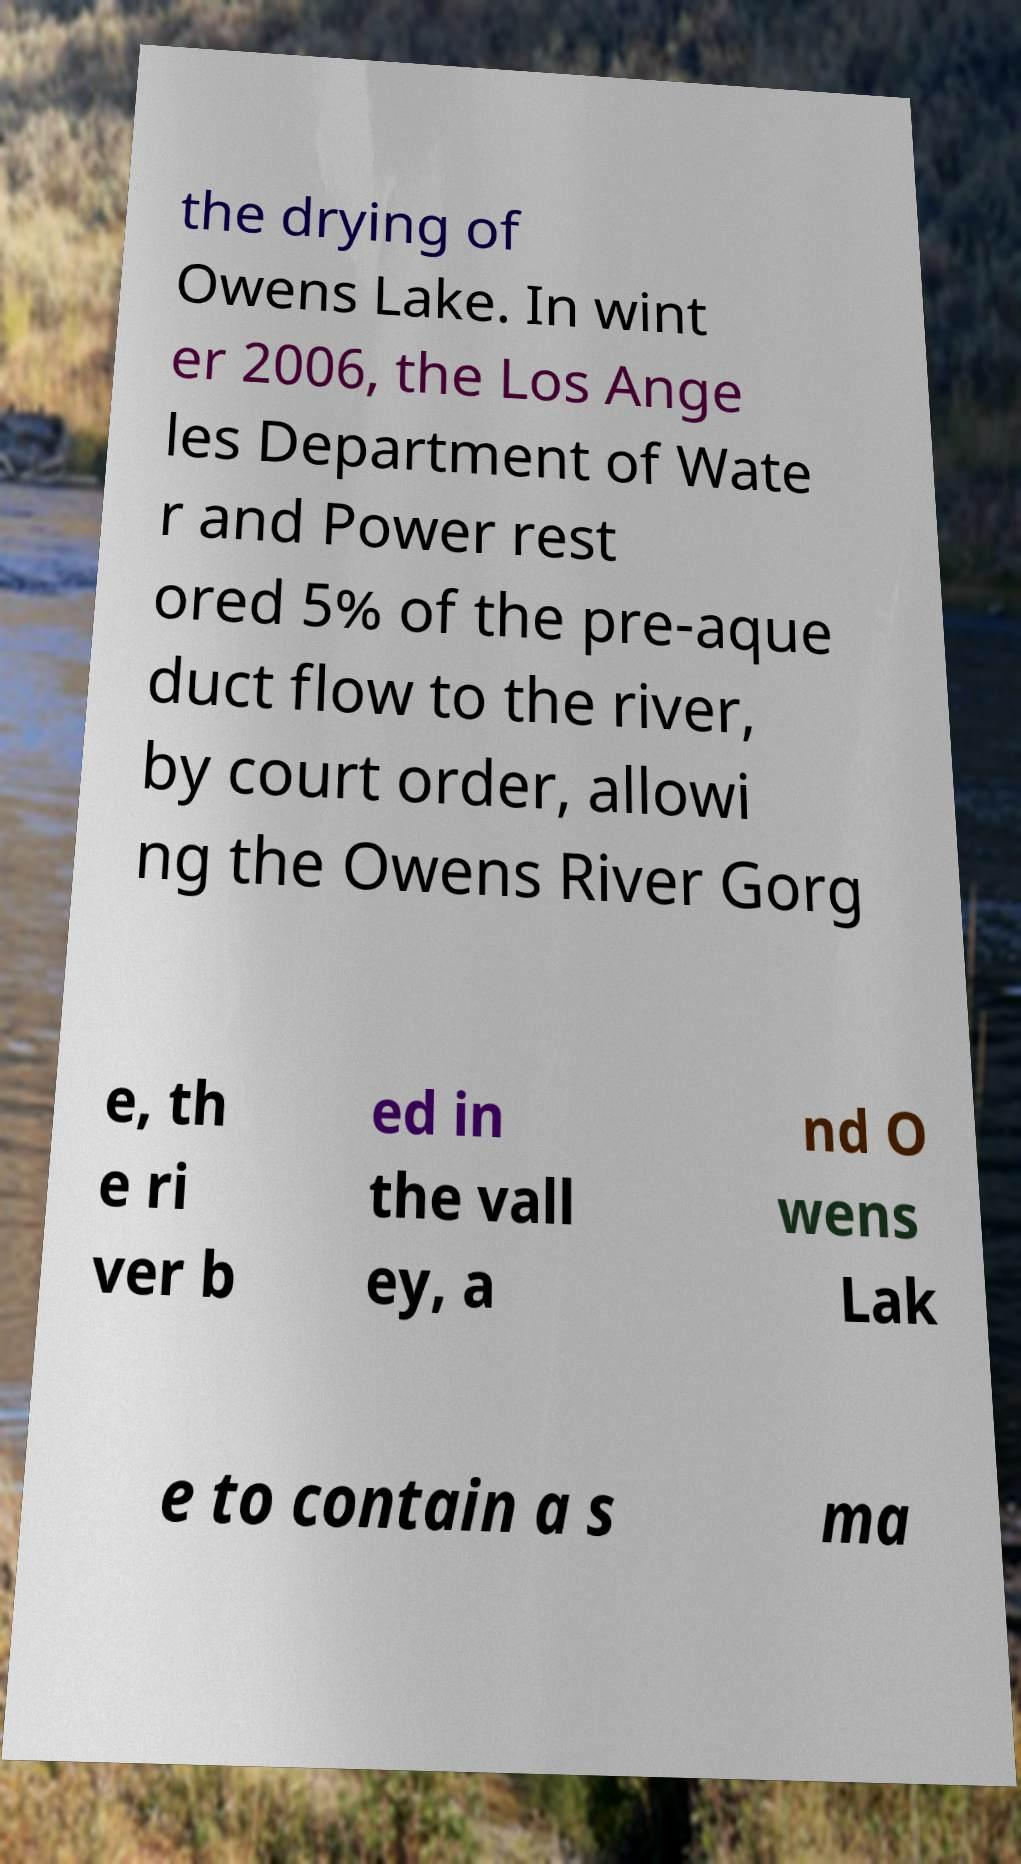Can you accurately transcribe the text from the provided image for me? the drying of Owens Lake. In wint er 2006, the Los Ange les Department of Wate r and Power rest ored 5% of the pre-aque duct flow to the river, by court order, allowi ng the Owens River Gorg e, th e ri ver b ed in the vall ey, a nd O wens Lak e to contain a s ma 